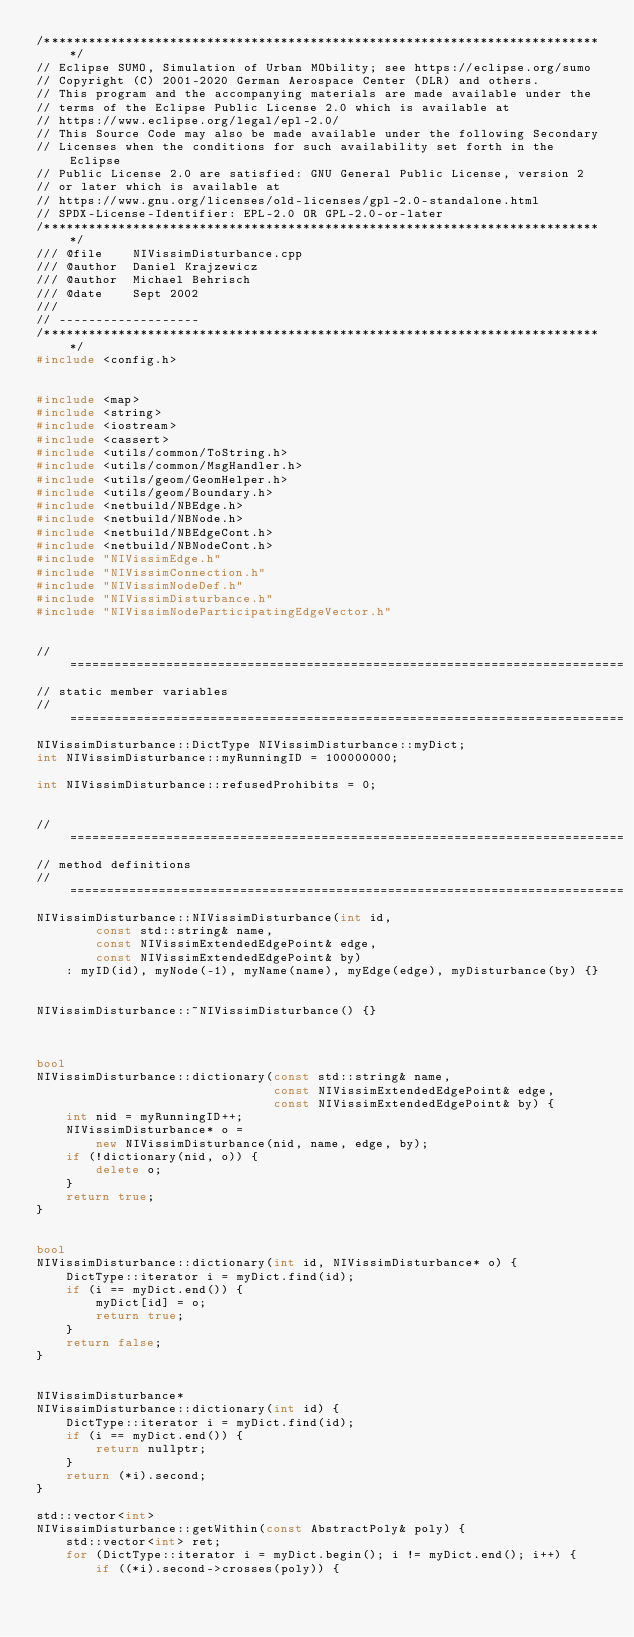<code> <loc_0><loc_0><loc_500><loc_500><_C++_>/****************************************************************************/
// Eclipse SUMO, Simulation of Urban MObility; see https://eclipse.org/sumo
// Copyright (C) 2001-2020 German Aerospace Center (DLR) and others.
// This program and the accompanying materials are made available under the
// terms of the Eclipse Public License 2.0 which is available at
// https://www.eclipse.org/legal/epl-2.0/
// This Source Code may also be made available under the following Secondary
// Licenses when the conditions for such availability set forth in the Eclipse
// Public License 2.0 are satisfied: GNU General Public License, version 2
// or later which is available at
// https://www.gnu.org/licenses/old-licenses/gpl-2.0-standalone.html
// SPDX-License-Identifier: EPL-2.0 OR GPL-2.0-or-later
/****************************************************************************/
/// @file    NIVissimDisturbance.cpp
/// @author  Daniel Krajzewicz
/// @author  Michael Behrisch
/// @date    Sept 2002
///
// -------------------
/****************************************************************************/
#include <config.h>


#include <map>
#include <string>
#include <iostream>
#include <cassert>
#include <utils/common/ToString.h>
#include <utils/common/MsgHandler.h>
#include <utils/geom/GeomHelper.h>
#include <utils/geom/Boundary.h>
#include <netbuild/NBEdge.h>
#include <netbuild/NBNode.h>
#include <netbuild/NBEdgeCont.h>
#include <netbuild/NBNodeCont.h>
#include "NIVissimEdge.h"
#include "NIVissimConnection.h"
#include "NIVissimNodeDef.h"
#include "NIVissimDisturbance.h"
#include "NIVissimNodeParticipatingEdgeVector.h"


// ===========================================================================
// static member variables
// ===========================================================================
NIVissimDisturbance::DictType NIVissimDisturbance::myDict;
int NIVissimDisturbance::myRunningID = 100000000;

int NIVissimDisturbance::refusedProhibits = 0;


// ===========================================================================
// method definitions
// ===========================================================================
NIVissimDisturbance::NIVissimDisturbance(int id,
        const std::string& name,
        const NIVissimExtendedEdgePoint& edge,
        const NIVissimExtendedEdgePoint& by)
    : myID(id), myNode(-1), myName(name), myEdge(edge), myDisturbance(by) {}


NIVissimDisturbance::~NIVissimDisturbance() {}



bool
NIVissimDisturbance::dictionary(const std::string& name,
                                const NIVissimExtendedEdgePoint& edge,
                                const NIVissimExtendedEdgePoint& by) {
    int nid = myRunningID++;
    NIVissimDisturbance* o =
        new NIVissimDisturbance(nid, name, edge, by);
    if (!dictionary(nid, o)) {
        delete o;
    }
    return true;
}


bool
NIVissimDisturbance::dictionary(int id, NIVissimDisturbance* o) {
    DictType::iterator i = myDict.find(id);
    if (i == myDict.end()) {
        myDict[id] = o;
        return true;
    }
    return false;
}


NIVissimDisturbance*
NIVissimDisturbance::dictionary(int id) {
    DictType::iterator i = myDict.find(id);
    if (i == myDict.end()) {
        return nullptr;
    }
    return (*i).second;
}

std::vector<int>
NIVissimDisturbance::getWithin(const AbstractPoly& poly) {
    std::vector<int> ret;
    for (DictType::iterator i = myDict.begin(); i != myDict.end(); i++) {
        if ((*i).second->crosses(poly)) {</code> 